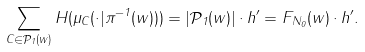Convert formula to latex. <formula><loc_0><loc_0><loc_500><loc_500>\sum _ { C \in \mathcal { P } _ { 1 } ( w ) } H ( \mu _ { C } ( \cdot | \pi ^ { - 1 } ( w ) ) ) = | \mathcal { P } _ { 1 } ( w ) | \cdot h ^ { \prime } = F _ { N _ { 0 } } ( w ) \cdot h ^ { \prime } .</formula> 